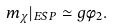Convert formula to latex. <formula><loc_0><loc_0><loc_500><loc_500>m _ { \chi } | _ { E S P } \simeq g \phi _ { 2 } .</formula> 